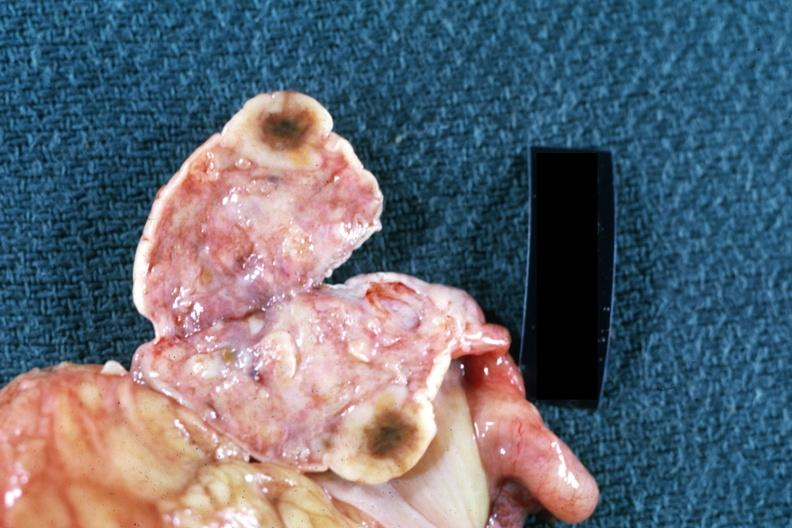what is present?
Answer the question using a single word or phrase. Ovary 